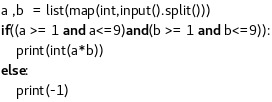<code> <loc_0><loc_0><loc_500><loc_500><_Python_>a ,b  = list(map(int,input().split()))
if((a >= 1 and a<=9)and(b >= 1 and b<=9)):
    print(int(a*b))
else:
    print(-1)</code> 